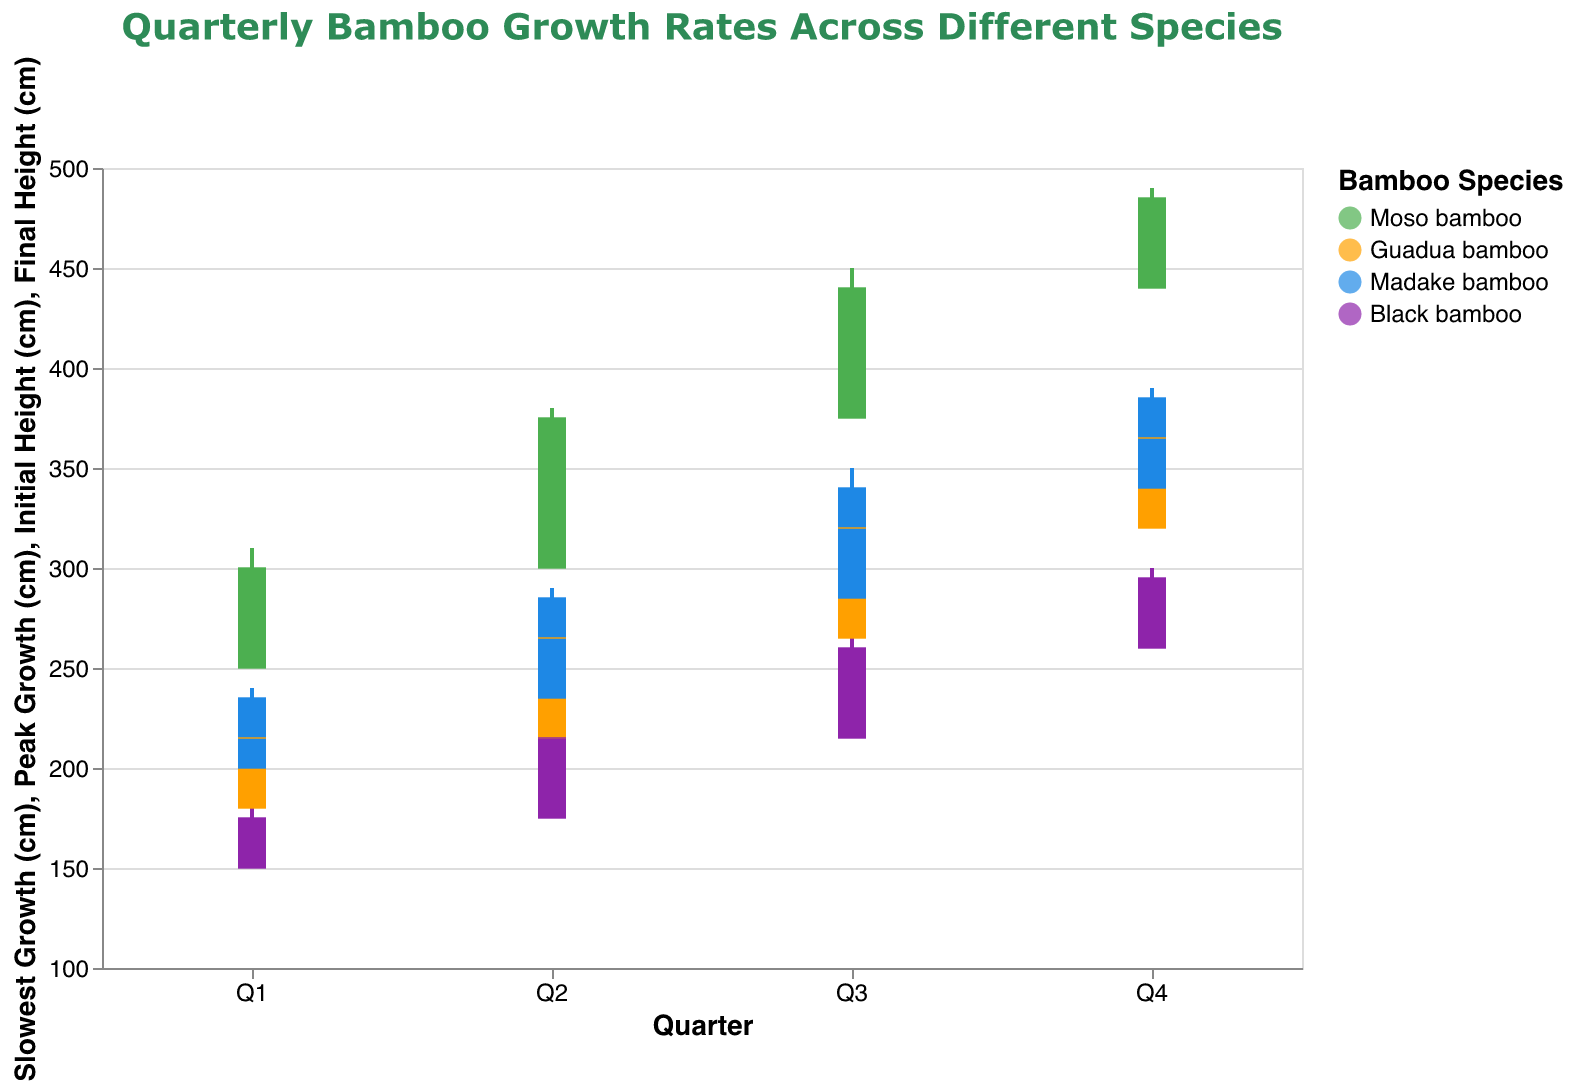Which bamboo species reaches the highest peak growth in any quarter? To determine the highest peak growth, examine the "Peak Growth (cm)" of each bamboo species across all quarters. Moso bamboo reaches a peak growth of 490 cm in Q4, which is the highest among all species and quarters.
Answer: Moso bamboo How does the final height of Black bamboo in Q4 compare to its initial height in Q4? Check the initial and final heights of Black bamboo in Q4. The initial height is 260 cm, and the final height is 295 cm. The final height is greater by 35 cm.
Answer: Greater by 35 cm What are the peak and slowest growth rates of Guadua bamboo in Q3? Look at the "Peak Growth (cm)" and "Slowest Growth (cm)" for Guadua bamboo in Q3. The peak growth rate is 330 cm, and the slowest growth rate is 275 cm.
Answer: 330 cm and 275 cm What is the average final height of Moso bamboo across all quarters? Calculate the average of final heights for Moso bamboo over Q1, Q2, Q3, and Q4. The final heights are 300, 375, 440, and 485 cm. The average is (300 + 375 + 440 + 485) / 4 = 400 cm.
Answer: 400 cm Which quarter shows the highest initial height for any bamboo species and what is its height? Examine the "Initial Height (cm)" for all species in each quarter. The highest initial height is for Moso bamboo in Q4, which is 440 cm.
Answer: Q4, 440 cm Compare the final height of Madake bamboo in Q2 to its initial height in Q2. Is it an increase or decrease and by how much? Examine the initial and final heights of Madake bamboo in Q2. The initial height is 235 cm, and the final height is 285 cm. The final height shows an increase of 50 cm.
Answer: Increase by 50 cm What is the slowest growth rate for Madake bamboo across all quarters? Find the lowest value in the "Slowest Growth (cm)" column for Madake bamboo from Q1 to Q4. The values are 205, 245, 295, and 345 cm. The slowest growth rate is 205 cm in Q1.
Answer: 205 cm Which species shows the highest growth (difference between peak and slowest growth) in Q1, and what is the difference? Calculate the difference between "Peak Growth (cm)" and "Slowest Growth (cm)" for each species in Q1. The differences are 50 cm for Moso bamboo, 35 cm for Guadua bamboo, 35 cm for Madake bamboo, and 25 cm for Black bamboo. The highest growth is by Moso bamboo with a difference of 50 cm.
Answer: Moso bamboo, 50 cm 